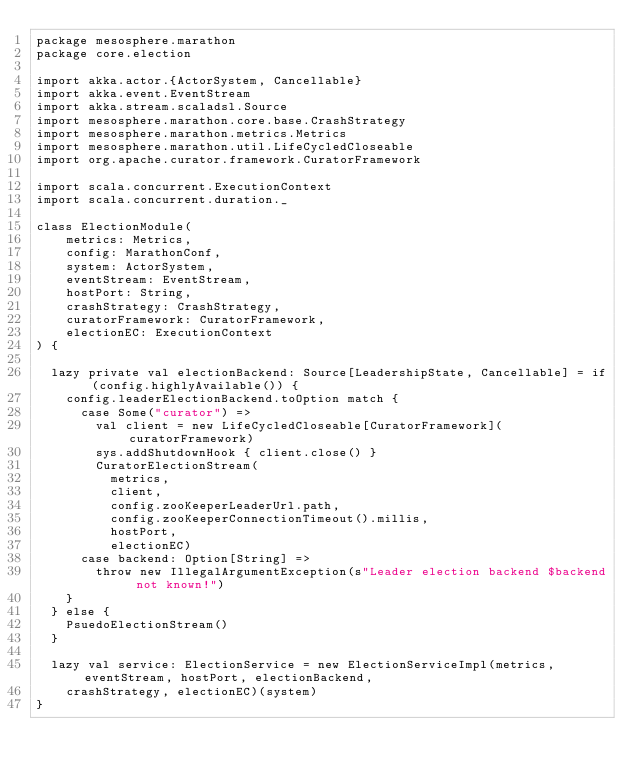<code> <loc_0><loc_0><loc_500><loc_500><_Scala_>package mesosphere.marathon
package core.election

import akka.actor.{ActorSystem, Cancellable}
import akka.event.EventStream
import akka.stream.scaladsl.Source
import mesosphere.marathon.core.base.CrashStrategy
import mesosphere.marathon.metrics.Metrics
import mesosphere.marathon.util.LifeCycledCloseable
import org.apache.curator.framework.CuratorFramework

import scala.concurrent.ExecutionContext
import scala.concurrent.duration._

class ElectionModule(
    metrics: Metrics,
    config: MarathonConf,
    system: ActorSystem,
    eventStream: EventStream,
    hostPort: String,
    crashStrategy: CrashStrategy,
    curatorFramework: CuratorFramework,
    electionEC: ExecutionContext
) {

  lazy private val electionBackend: Source[LeadershipState, Cancellable] = if (config.highlyAvailable()) {
    config.leaderElectionBackend.toOption match {
      case Some("curator") =>
        val client = new LifeCycledCloseable[CuratorFramework](curatorFramework)
        sys.addShutdownHook { client.close() }
        CuratorElectionStream(
          metrics,
          client,
          config.zooKeeperLeaderUrl.path,
          config.zooKeeperConnectionTimeout().millis,
          hostPort,
          electionEC)
      case backend: Option[String] =>
        throw new IllegalArgumentException(s"Leader election backend $backend not known!")
    }
  } else {
    PsuedoElectionStream()
  }

  lazy val service: ElectionService = new ElectionServiceImpl(metrics, eventStream, hostPort, electionBackend,
    crashStrategy, electionEC)(system)
}
</code> 